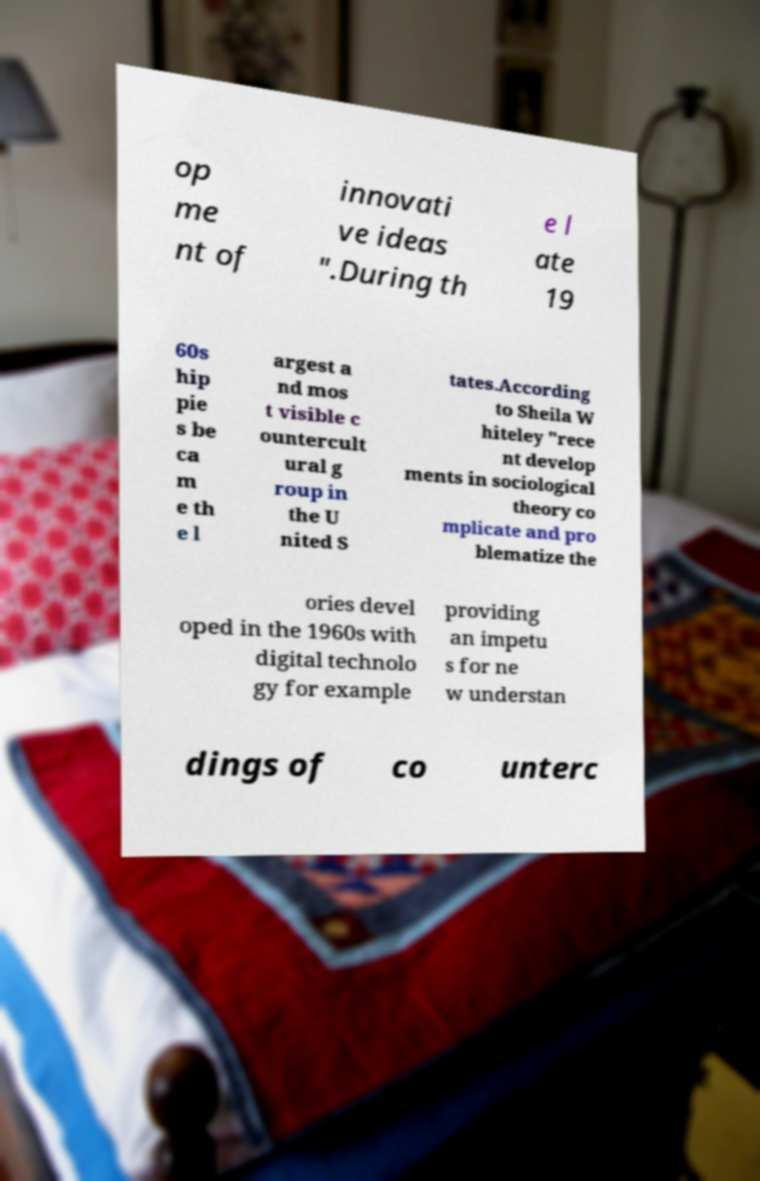Please identify and transcribe the text found in this image. op me nt of innovati ve ideas ".During th e l ate 19 60s hip pie s be ca m e th e l argest a nd mos t visible c ountercult ural g roup in the U nited S tates.According to Sheila W hiteley "rece nt develop ments in sociological theory co mplicate and pro blematize the ories devel oped in the 1960s with digital technolo gy for example providing an impetu s for ne w understan dings of co unterc 